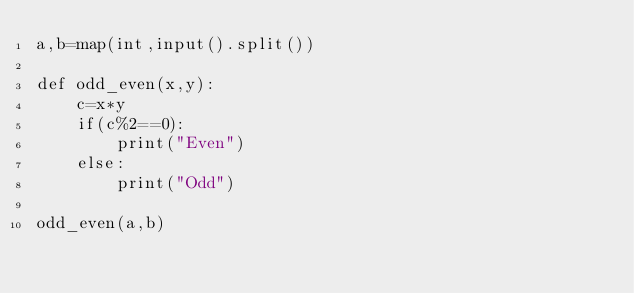<code> <loc_0><loc_0><loc_500><loc_500><_Python_>a,b=map(int,input().split())

def odd_even(x,y):
    c=x*y
    if(c%2==0):
        print("Even")
    else:
        print("Odd")
        
odd_even(a,b)</code> 